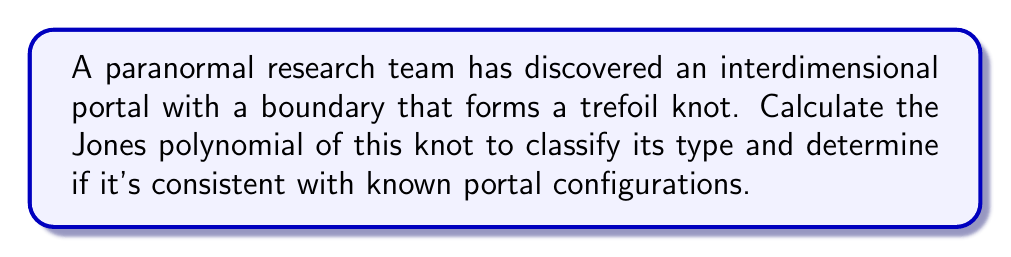Teach me how to tackle this problem. To classify the knot type of the interdimensional portal's boundary using the Jones polynomial, we'll follow these steps:

1. Recognize that the boundary forms a trefoil knot.

2. Recall the skein relation for the Jones polynomial:
   $$t^{-1}V(L_+) - tV(L_-) = (t^{1/2} - t^{-1/2})V(L_0)$$
   where $L_+$, $L_-$, and $L_0$ represent positive crossing, negative crossing, and smoothing, respectively.

3. For the trefoil knot, we can use the following diagram:
   [asy]
   import geometry;

   size(100);
   
   path trefoil = (0,0)..(-1,1)..(0,2)..(1,1)..(0,0)..(1,-1)..(2,0)..(1,1);
   draw(trefoil, blue+linewidth(1));
   
   dot((0,0), red);
   dot((1,1), red);
   dot((0,2), red);
   [/asy]

4. Apply the skein relation recursively:
   $$V(\text{trefoil}) = t^{-1}V(\text{Hopf link}) - t^{1/2}V(\text{unknot})$$

5. We know that $V(\text{unknot}) = 1$ and $V(\text{Hopf link}) = -t^{1/2} - t^{-3/2}$

6. Substitute these values:
   $$V(\text{trefoil}) = t^{-1}(-t^{1/2} - t^{-3/2}) - t^{1/2}$$

7. Simplify:
   $$V(\text{trefoil}) = -t^{-1/2} - t^{-5/2} - t^{1/2}$$

8. The final Jones polynomial for the trefoil knot is:
   $$V(\text{trefoil}) = t^{-1} + t^{-3} - t^{-4}$$

This polynomial uniquely identifies the trefoil knot and confirms that the portal's boundary is indeed a trefoil knot.
Answer: $t^{-1} + t^{-3} - t^{-4}$ 